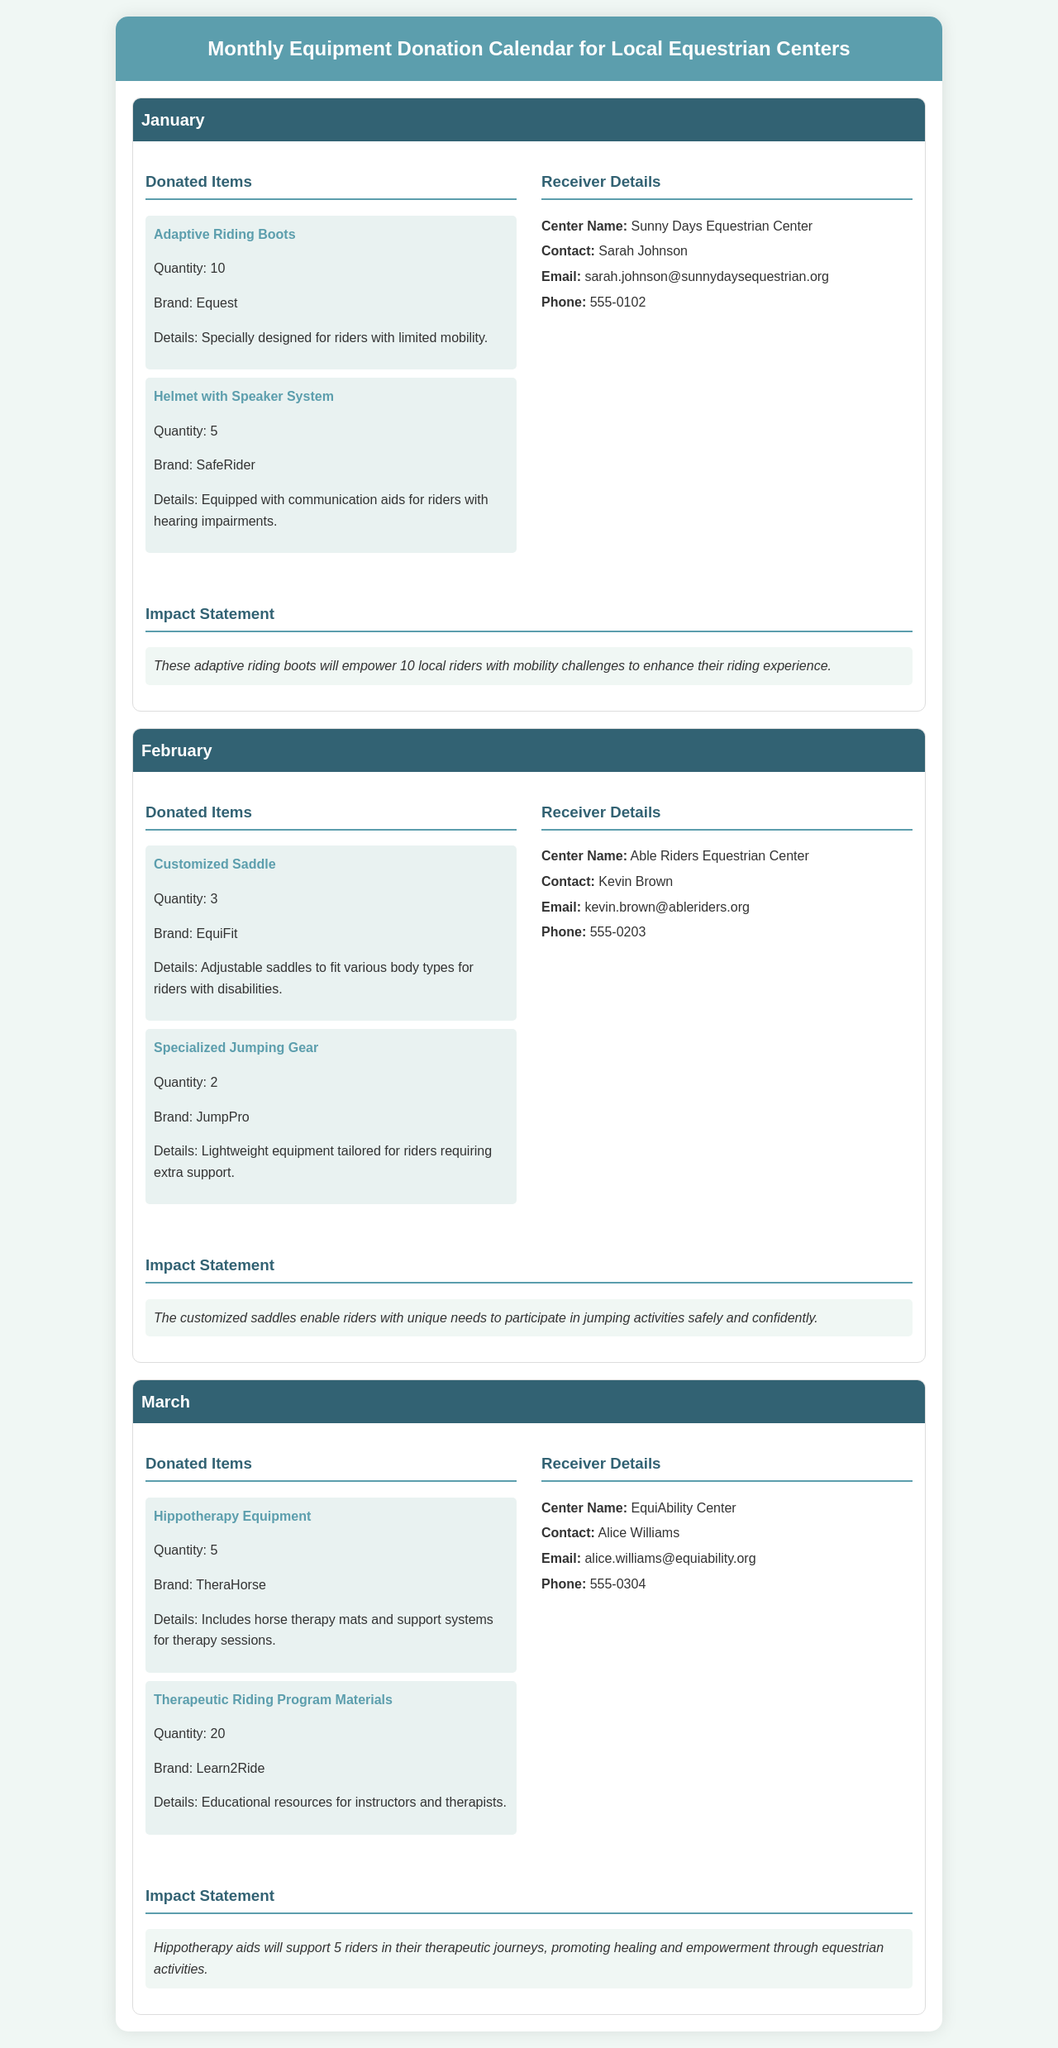what items were donated in January? The document lists the items donated in January, which are Adaptive Riding Boots and Helmet with Speaker System.
Answer: Adaptive Riding Boots, Helmet with Speaker System how many Adaptive Riding Boots were donated? The quantity of Adaptive Riding Boots donated is specified in the document.
Answer: 10 who is the contact person at Able Riders Equestrian Center? The document provides contact information for the receiver details of the February donations.
Answer: Kevin Brown what is the impact of the customized saddles donated in February? The document describes the impact of the customized saddles, emphasizing their benefit for riders with unique needs in jumping activities.
Answer: Safe and confident participation in jumping activities how many pieces of Hippotherapy Equipment were donated in March? The document states the total quantity of Hippotherapy Equipment donated in March.
Answer: 5 which equestrian center received the donation of therapeutic riding program materials? The document states the name of the center that received the therapeutic riding program materials for March.
Answer: EquiAbility Center how many specialized jumping gear were donated in February? The quantity of specialized jumping gear donated in February is mentioned in the document.
Answer: 2 what brand is responsible for the Helmet with Speaker System? The document specifies the brand associated with the Helmet with Speaker System donated in January.
Answer: SafeRider 